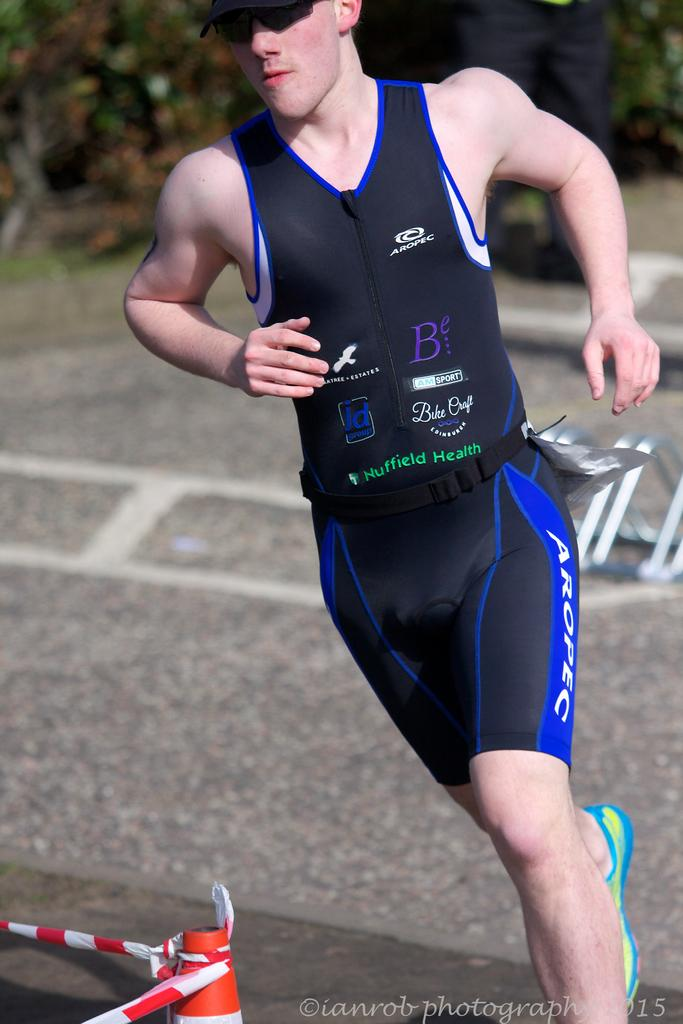<image>
Create a compact narrative representing the image presented. Advertisements for JD Group, Bike Craft, and Nuffield Health decorate the uniform of an athlete in motion. 